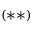Convert formula to latex. <formula><loc_0><loc_0><loc_500><loc_500>( \ast \ast )</formula> 